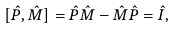Convert formula to latex. <formula><loc_0><loc_0><loc_500><loc_500>[ \hat { P } , \hat { M } ] = \hat { P } \hat { M } - \hat { M } \hat { P } = \hat { I } ,</formula> 